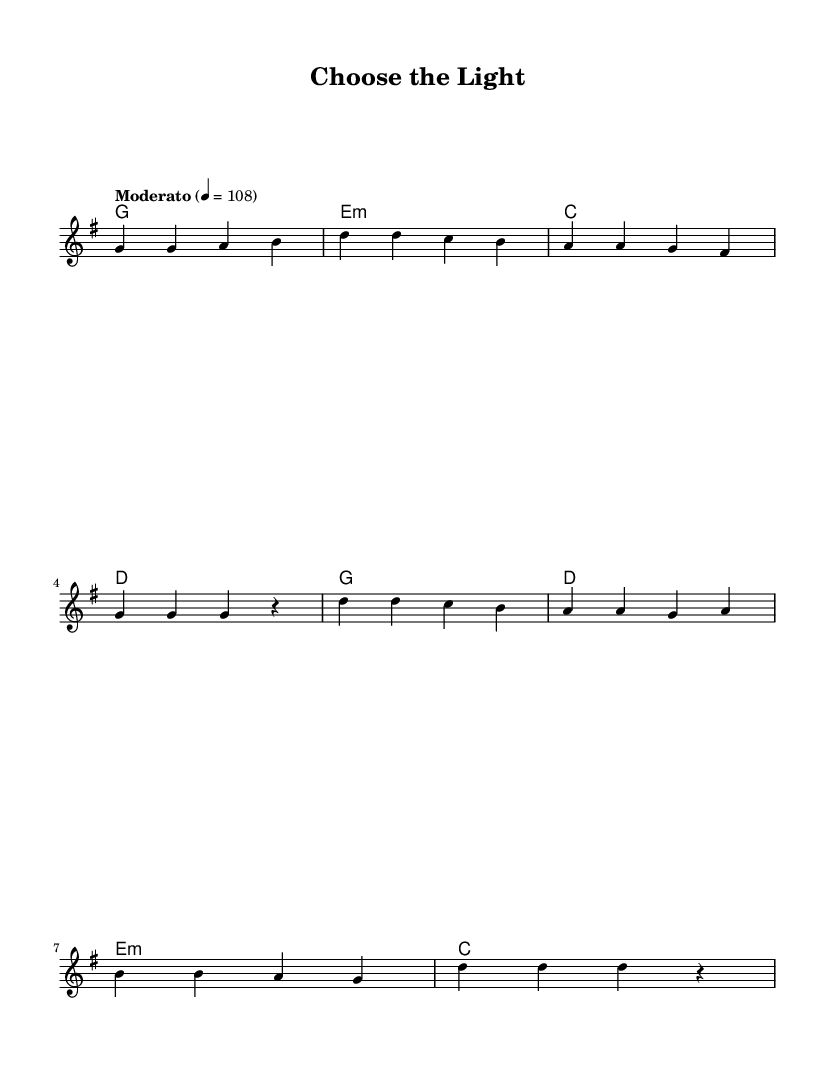What is the key signature of this music? The key signature is indicated at the beginning of the staff. In this case, there is one sharp which signifies the key of G major.
Answer: G major What is the time signature of this music? The time signature can also be found at the beginning of the score. Here, it is 4/4, which means there are four beats in a measure and the quarter note gets one beat.
Answer: 4/4 What is the tempo marking for this piece? The tempo marking is indicated above the staff. It states "Moderato" which generally means a moderate pace, and it's usually set at a tempo of 108 beats per minute.
Answer: 108 How many measures are in the verse? The verse section is composed of eight measures as you can count the groupings of bars indicated in the melody and lyrics combined.
Answer: 8 What is the primary theme of the lyrics? The lyrics focus on the concept of choosing positivity and light over negativity, which reflects a central message of inspiration found in Christian pop music.
Answer: Choose the light How does the chorus differ from the verse in terms of structure? The chorus generally has a more repetitive structure, focusing on the thematic message, while the verse offers more narrative detail. In the score, the chorus has fewer measures and repeats key phrases.
Answer: Repetitive 